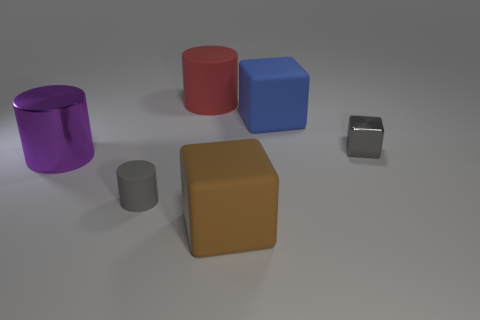Add 1 large red things. How many objects exist? 7 Add 3 blue rubber cubes. How many blue rubber cubes are left? 4 Add 5 large metallic objects. How many large metallic objects exist? 6 Subtract 0 purple cubes. How many objects are left? 6 Subtract all green cylinders. Subtract all tiny gray matte things. How many objects are left? 5 